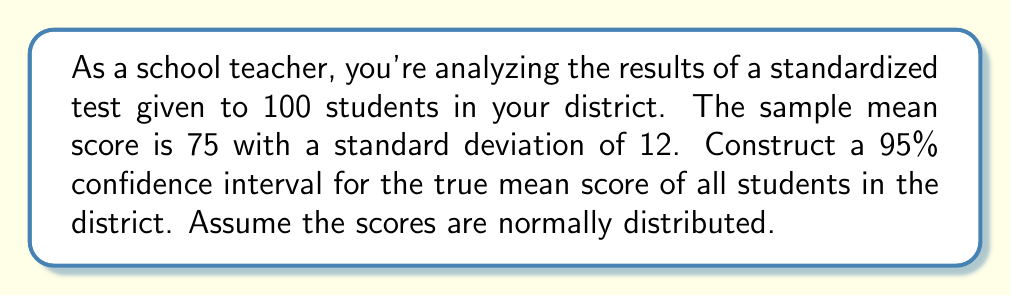Help me with this question. To construct a 95% confidence interval, we'll follow these steps:

1. Identify the given information:
   - Sample size: $n = 100$
   - Sample mean: $\bar{x} = 75$
   - Sample standard deviation: $s = 12$
   - Confidence level: 95%

2. Determine the critical value:
   For a 95% confidence interval, we use a z-score of 1.96.

3. Calculate the standard error of the mean:
   $SE = \frac{s}{\sqrt{n}} = \frac{12}{\sqrt{100}} = \frac{12}{10} = 1.2$

4. Calculate the margin of error:
   $ME = z \cdot SE = 1.96 \cdot 1.2 = 2.352$

5. Construct the confidence interval:
   $CI = \bar{x} \pm ME$
   $CI = 75 \pm 2.352$
   $CI = (72.648, 77.352)$

Therefore, we can be 95% confident that the true mean score for all students in the district falls between 72.648 and 77.352.
Answer: (72.648, 77.352) 